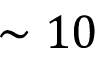<formula> <loc_0><loc_0><loc_500><loc_500>\sim 1 0</formula> 